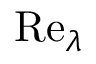Convert formula to latex. <formula><loc_0><loc_0><loc_500><loc_500>R e _ { \lambda }</formula> 